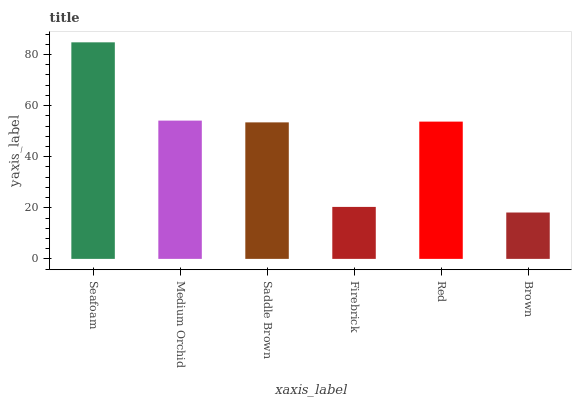Is Brown the minimum?
Answer yes or no. Yes. Is Seafoam the maximum?
Answer yes or no. Yes. Is Medium Orchid the minimum?
Answer yes or no. No. Is Medium Orchid the maximum?
Answer yes or no. No. Is Seafoam greater than Medium Orchid?
Answer yes or no. Yes. Is Medium Orchid less than Seafoam?
Answer yes or no. Yes. Is Medium Orchid greater than Seafoam?
Answer yes or no. No. Is Seafoam less than Medium Orchid?
Answer yes or no. No. Is Red the high median?
Answer yes or no. Yes. Is Saddle Brown the low median?
Answer yes or no. Yes. Is Firebrick the high median?
Answer yes or no. No. Is Medium Orchid the low median?
Answer yes or no. No. 